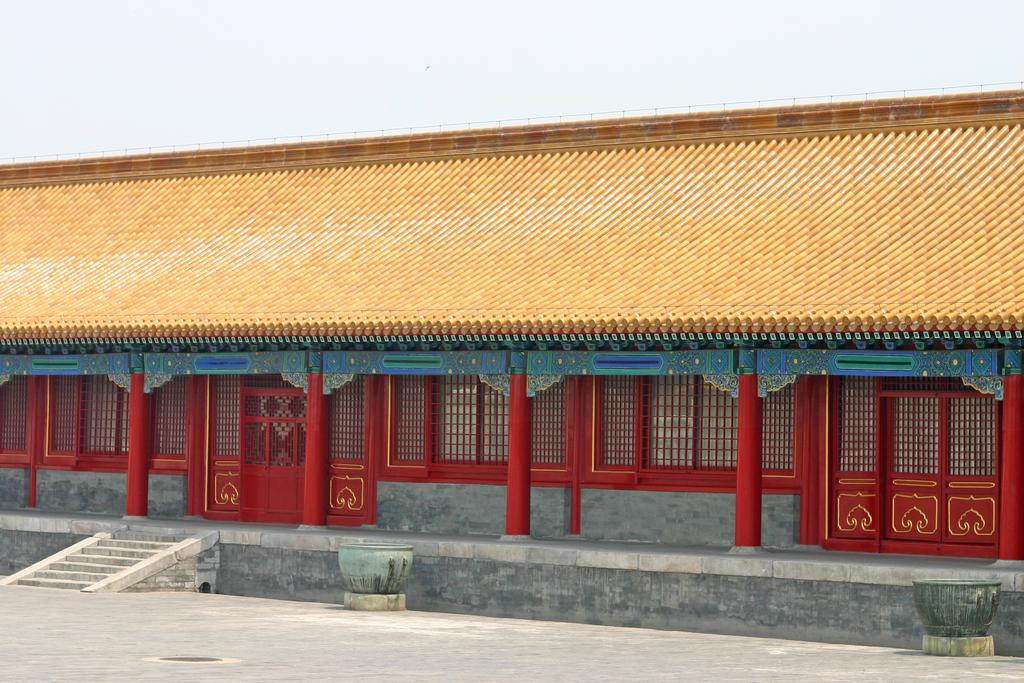What objects are on the floor in the image? There are pots on the floor in the image. What architectural feature can be seen in the image? There are steps, pillars, and a building visible in the image. What type of material is used for the wires in the image? Welded mesh wires are present in the image. What can be used for entering or exiting the building in the image? There are doors in the image. What part of the building is visible in the image? The roof is visible in the image. What is visible above the building in the image? The sky is visible in the image. How many carriages are parked in front of the building in the image? There are no carriages present in the image. What type of pin is holding the building together in the image? There is no pin holding the building together in the image; it is a solid structure. 